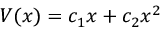<formula> <loc_0><loc_0><loc_500><loc_500>V ( x ) = { c _ { 1 } } x + { c _ { 2 } } x ^ { 2 }</formula> 